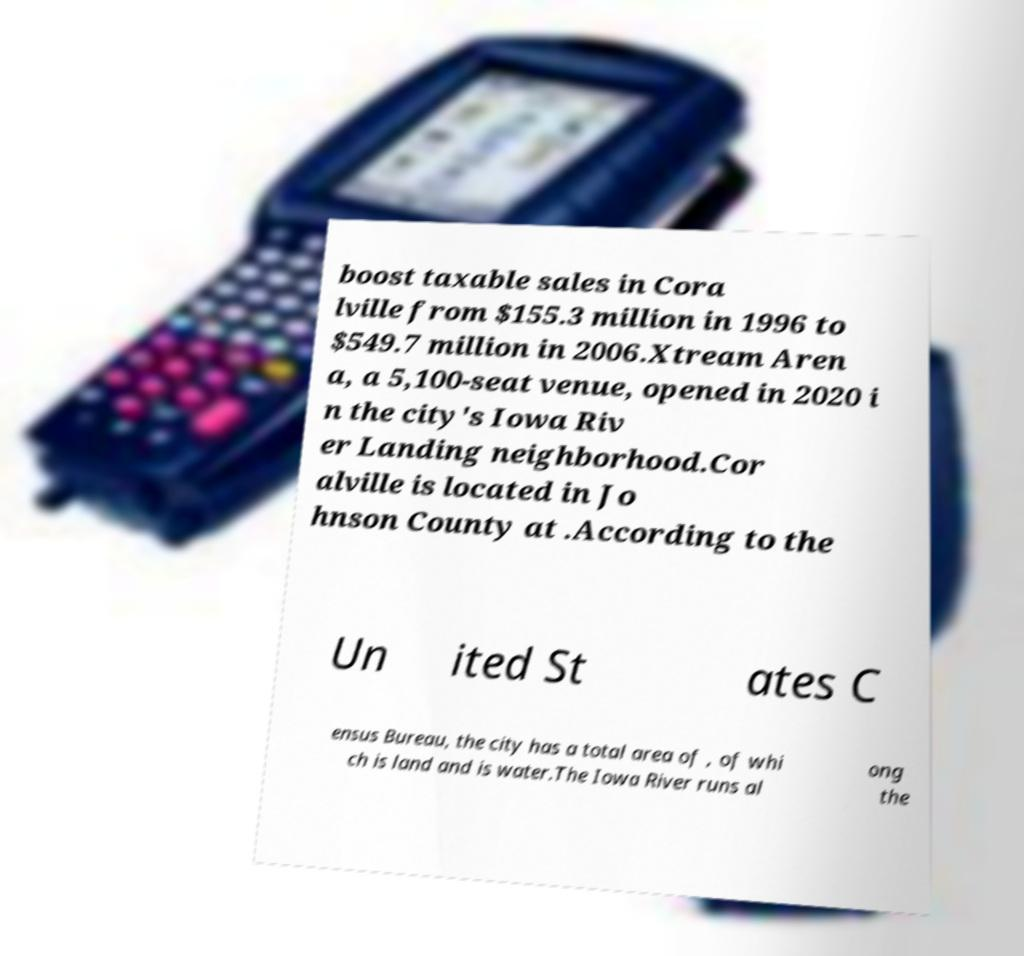For documentation purposes, I need the text within this image transcribed. Could you provide that? boost taxable sales in Cora lville from $155.3 million in 1996 to $549.7 million in 2006.Xtream Aren a, a 5,100-seat venue, opened in 2020 i n the city's Iowa Riv er Landing neighborhood.Cor alville is located in Jo hnson County at .According to the Un ited St ates C ensus Bureau, the city has a total area of , of whi ch is land and is water.The Iowa River runs al ong the 